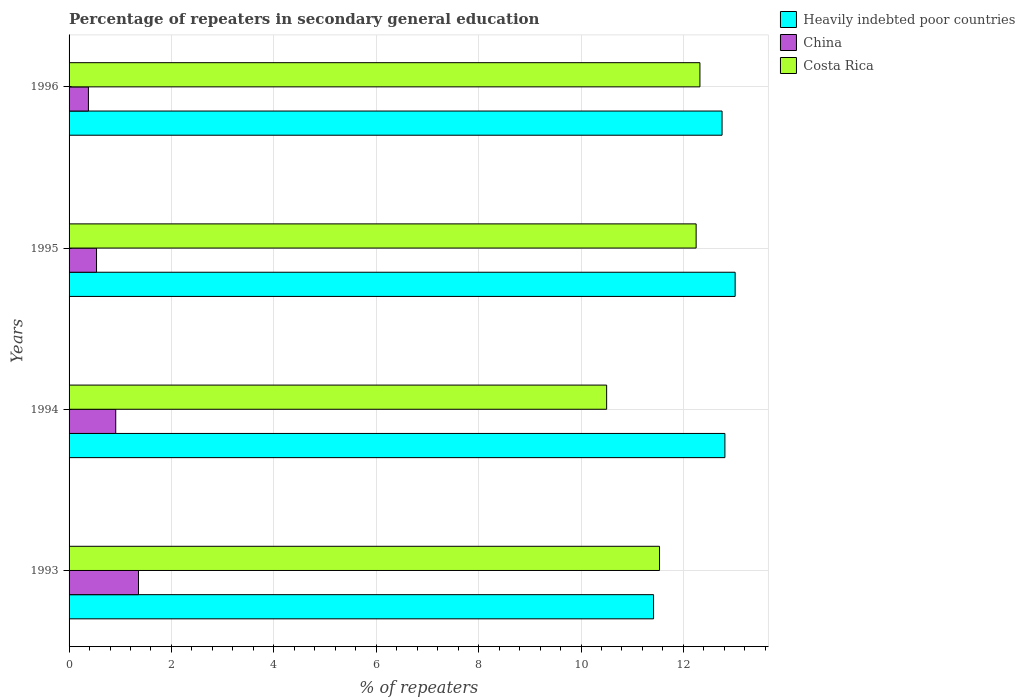How many different coloured bars are there?
Ensure brevity in your answer.  3. How many groups of bars are there?
Your answer should be compact. 4. Are the number of bars per tick equal to the number of legend labels?
Your answer should be compact. Yes. How many bars are there on the 1st tick from the bottom?
Provide a succinct answer. 3. In how many cases, is the number of bars for a given year not equal to the number of legend labels?
Your answer should be compact. 0. What is the percentage of repeaters in secondary general education in Costa Rica in 1996?
Provide a short and direct response. 12.32. Across all years, what is the maximum percentage of repeaters in secondary general education in Heavily indebted poor countries?
Offer a very short reply. 13.01. Across all years, what is the minimum percentage of repeaters in secondary general education in Costa Rica?
Give a very brief answer. 10.5. In which year was the percentage of repeaters in secondary general education in China maximum?
Make the answer very short. 1993. In which year was the percentage of repeaters in secondary general education in Heavily indebted poor countries minimum?
Ensure brevity in your answer.  1993. What is the total percentage of repeaters in secondary general education in Heavily indebted poor countries in the graph?
Give a very brief answer. 50. What is the difference between the percentage of repeaters in secondary general education in China in 1994 and that in 1995?
Your answer should be very brief. 0.38. What is the difference between the percentage of repeaters in secondary general education in Costa Rica in 1994 and the percentage of repeaters in secondary general education in Heavily indebted poor countries in 1993?
Your answer should be very brief. -0.92. What is the average percentage of repeaters in secondary general education in Costa Rica per year?
Your answer should be compact. 11.65. In the year 1995, what is the difference between the percentage of repeaters in secondary general education in China and percentage of repeaters in secondary general education in Heavily indebted poor countries?
Offer a terse response. -12.47. What is the ratio of the percentage of repeaters in secondary general education in China in 1994 to that in 1995?
Ensure brevity in your answer.  1.7. Is the difference between the percentage of repeaters in secondary general education in China in 1994 and 1996 greater than the difference between the percentage of repeaters in secondary general education in Heavily indebted poor countries in 1994 and 1996?
Give a very brief answer. Yes. What is the difference between the highest and the second highest percentage of repeaters in secondary general education in Heavily indebted poor countries?
Your response must be concise. 0.2. What is the difference between the highest and the lowest percentage of repeaters in secondary general education in Costa Rica?
Make the answer very short. 1.82. In how many years, is the percentage of repeaters in secondary general education in China greater than the average percentage of repeaters in secondary general education in China taken over all years?
Offer a very short reply. 2. What does the 3rd bar from the top in 1993 represents?
Give a very brief answer. Heavily indebted poor countries. Does the graph contain any zero values?
Offer a terse response. No. What is the title of the graph?
Ensure brevity in your answer.  Percentage of repeaters in secondary general education. Does "Greenland" appear as one of the legend labels in the graph?
Give a very brief answer. No. What is the label or title of the X-axis?
Make the answer very short. % of repeaters. What is the label or title of the Y-axis?
Provide a succinct answer. Years. What is the % of repeaters of Heavily indebted poor countries in 1993?
Keep it short and to the point. 11.42. What is the % of repeaters of China in 1993?
Your answer should be very brief. 1.36. What is the % of repeaters in Costa Rica in 1993?
Your answer should be very brief. 11.53. What is the % of repeaters in Heavily indebted poor countries in 1994?
Your answer should be compact. 12.81. What is the % of repeaters of China in 1994?
Provide a succinct answer. 0.91. What is the % of repeaters in Costa Rica in 1994?
Your answer should be compact. 10.5. What is the % of repeaters in Heavily indebted poor countries in 1995?
Provide a short and direct response. 13.01. What is the % of repeaters in China in 1995?
Offer a terse response. 0.54. What is the % of repeaters of Costa Rica in 1995?
Ensure brevity in your answer.  12.25. What is the % of repeaters of Heavily indebted poor countries in 1996?
Provide a short and direct response. 12.76. What is the % of repeaters in China in 1996?
Give a very brief answer. 0.38. What is the % of repeaters in Costa Rica in 1996?
Offer a terse response. 12.32. Across all years, what is the maximum % of repeaters in Heavily indebted poor countries?
Offer a terse response. 13.01. Across all years, what is the maximum % of repeaters in China?
Give a very brief answer. 1.36. Across all years, what is the maximum % of repeaters of Costa Rica?
Your answer should be very brief. 12.32. Across all years, what is the minimum % of repeaters in Heavily indebted poor countries?
Provide a short and direct response. 11.42. Across all years, what is the minimum % of repeaters of China?
Ensure brevity in your answer.  0.38. Across all years, what is the minimum % of repeaters of Costa Rica?
Make the answer very short. 10.5. What is the total % of repeaters of Heavily indebted poor countries in the graph?
Make the answer very short. 50. What is the total % of repeaters of China in the graph?
Offer a terse response. 3.18. What is the total % of repeaters in Costa Rica in the graph?
Your answer should be very brief. 46.61. What is the difference between the % of repeaters in Heavily indebted poor countries in 1993 and that in 1994?
Give a very brief answer. -1.39. What is the difference between the % of repeaters in China in 1993 and that in 1994?
Provide a short and direct response. 0.44. What is the difference between the % of repeaters in Costa Rica in 1993 and that in 1994?
Provide a short and direct response. 1.03. What is the difference between the % of repeaters of Heavily indebted poor countries in 1993 and that in 1995?
Offer a terse response. -1.59. What is the difference between the % of repeaters in China in 1993 and that in 1995?
Your answer should be very brief. 0.82. What is the difference between the % of repeaters in Costa Rica in 1993 and that in 1995?
Your answer should be very brief. -0.72. What is the difference between the % of repeaters of Heavily indebted poor countries in 1993 and that in 1996?
Provide a short and direct response. -1.34. What is the difference between the % of repeaters of China in 1993 and that in 1996?
Provide a succinct answer. 0.98. What is the difference between the % of repeaters of Costa Rica in 1993 and that in 1996?
Keep it short and to the point. -0.79. What is the difference between the % of repeaters in Heavily indebted poor countries in 1994 and that in 1995?
Your answer should be compact. -0.2. What is the difference between the % of repeaters in China in 1994 and that in 1995?
Your answer should be compact. 0.38. What is the difference between the % of repeaters in Costa Rica in 1994 and that in 1995?
Keep it short and to the point. -1.75. What is the difference between the % of repeaters of Heavily indebted poor countries in 1994 and that in 1996?
Your answer should be compact. 0.06. What is the difference between the % of repeaters in China in 1994 and that in 1996?
Provide a succinct answer. 0.53. What is the difference between the % of repeaters in Costa Rica in 1994 and that in 1996?
Keep it short and to the point. -1.82. What is the difference between the % of repeaters of Heavily indebted poor countries in 1995 and that in 1996?
Offer a terse response. 0.26. What is the difference between the % of repeaters of China in 1995 and that in 1996?
Give a very brief answer. 0.16. What is the difference between the % of repeaters of Costa Rica in 1995 and that in 1996?
Your answer should be compact. -0.07. What is the difference between the % of repeaters of Heavily indebted poor countries in 1993 and the % of repeaters of China in 1994?
Your answer should be very brief. 10.51. What is the difference between the % of repeaters in Heavily indebted poor countries in 1993 and the % of repeaters in Costa Rica in 1994?
Make the answer very short. 0.92. What is the difference between the % of repeaters in China in 1993 and the % of repeaters in Costa Rica in 1994?
Provide a succinct answer. -9.14. What is the difference between the % of repeaters of Heavily indebted poor countries in 1993 and the % of repeaters of China in 1995?
Ensure brevity in your answer.  10.88. What is the difference between the % of repeaters in Heavily indebted poor countries in 1993 and the % of repeaters in Costa Rica in 1995?
Keep it short and to the point. -0.83. What is the difference between the % of repeaters of China in 1993 and the % of repeaters of Costa Rica in 1995?
Offer a very short reply. -10.89. What is the difference between the % of repeaters in Heavily indebted poor countries in 1993 and the % of repeaters in China in 1996?
Your answer should be very brief. 11.04. What is the difference between the % of repeaters in Heavily indebted poor countries in 1993 and the % of repeaters in Costa Rica in 1996?
Provide a succinct answer. -0.91. What is the difference between the % of repeaters of China in 1993 and the % of repeaters of Costa Rica in 1996?
Make the answer very short. -10.97. What is the difference between the % of repeaters of Heavily indebted poor countries in 1994 and the % of repeaters of China in 1995?
Offer a very short reply. 12.27. What is the difference between the % of repeaters of Heavily indebted poor countries in 1994 and the % of repeaters of Costa Rica in 1995?
Keep it short and to the point. 0.56. What is the difference between the % of repeaters in China in 1994 and the % of repeaters in Costa Rica in 1995?
Your answer should be very brief. -11.34. What is the difference between the % of repeaters of Heavily indebted poor countries in 1994 and the % of repeaters of China in 1996?
Your answer should be very brief. 12.43. What is the difference between the % of repeaters in Heavily indebted poor countries in 1994 and the % of repeaters in Costa Rica in 1996?
Your response must be concise. 0.49. What is the difference between the % of repeaters in China in 1994 and the % of repeaters in Costa Rica in 1996?
Your answer should be very brief. -11.41. What is the difference between the % of repeaters in Heavily indebted poor countries in 1995 and the % of repeaters in China in 1996?
Provide a short and direct response. 12.63. What is the difference between the % of repeaters in Heavily indebted poor countries in 1995 and the % of repeaters in Costa Rica in 1996?
Offer a very short reply. 0.69. What is the difference between the % of repeaters in China in 1995 and the % of repeaters in Costa Rica in 1996?
Your response must be concise. -11.79. What is the average % of repeaters in Heavily indebted poor countries per year?
Your response must be concise. 12.5. What is the average % of repeaters in China per year?
Give a very brief answer. 0.8. What is the average % of repeaters of Costa Rica per year?
Offer a terse response. 11.65. In the year 1993, what is the difference between the % of repeaters of Heavily indebted poor countries and % of repeaters of China?
Your answer should be compact. 10.06. In the year 1993, what is the difference between the % of repeaters of Heavily indebted poor countries and % of repeaters of Costa Rica?
Offer a terse response. -0.12. In the year 1993, what is the difference between the % of repeaters in China and % of repeaters in Costa Rica?
Make the answer very short. -10.18. In the year 1994, what is the difference between the % of repeaters in Heavily indebted poor countries and % of repeaters in China?
Provide a short and direct response. 11.9. In the year 1994, what is the difference between the % of repeaters in Heavily indebted poor countries and % of repeaters in Costa Rica?
Give a very brief answer. 2.31. In the year 1994, what is the difference between the % of repeaters of China and % of repeaters of Costa Rica?
Make the answer very short. -9.59. In the year 1995, what is the difference between the % of repeaters of Heavily indebted poor countries and % of repeaters of China?
Ensure brevity in your answer.  12.47. In the year 1995, what is the difference between the % of repeaters in Heavily indebted poor countries and % of repeaters in Costa Rica?
Your answer should be very brief. 0.76. In the year 1995, what is the difference between the % of repeaters in China and % of repeaters in Costa Rica?
Give a very brief answer. -11.71. In the year 1996, what is the difference between the % of repeaters in Heavily indebted poor countries and % of repeaters in China?
Your answer should be very brief. 12.38. In the year 1996, what is the difference between the % of repeaters of Heavily indebted poor countries and % of repeaters of Costa Rica?
Offer a very short reply. 0.43. In the year 1996, what is the difference between the % of repeaters in China and % of repeaters in Costa Rica?
Offer a terse response. -11.95. What is the ratio of the % of repeaters of Heavily indebted poor countries in 1993 to that in 1994?
Ensure brevity in your answer.  0.89. What is the ratio of the % of repeaters of China in 1993 to that in 1994?
Offer a terse response. 1.49. What is the ratio of the % of repeaters in Costa Rica in 1993 to that in 1994?
Provide a short and direct response. 1.1. What is the ratio of the % of repeaters of Heavily indebted poor countries in 1993 to that in 1995?
Your answer should be very brief. 0.88. What is the ratio of the % of repeaters of China in 1993 to that in 1995?
Provide a short and direct response. 2.53. What is the ratio of the % of repeaters of Costa Rica in 1993 to that in 1995?
Your answer should be very brief. 0.94. What is the ratio of the % of repeaters of Heavily indebted poor countries in 1993 to that in 1996?
Ensure brevity in your answer.  0.9. What is the ratio of the % of repeaters in China in 1993 to that in 1996?
Your answer should be compact. 3.59. What is the ratio of the % of repeaters in Costa Rica in 1993 to that in 1996?
Offer a very short reply. 0.94. What is the ratio of the % of repeaters of Heavily indebted poor countries in 1994 to that in 1995?
Give a very brief answer. 0.98. What is the ratio of the % of repeaters of China in 1994 to that in 1995?
Offer a terse response. 1.7. What is the ratio of the % of repeaters of Costa Rica in 1994 to that in 1995?
Your answer should be compact. 0.86. What is the ratio of the % of repeaters of Heavily indebted poor countries in 1994 to that in 1996?
Offer a very short reply. 1. What is the ratio of the % of repeaters in China in 1994 to that in 1996?
Make the answer very short. 2.41. What is the ratio of the % of repeaters in Costa Rica in 1994 to that in 1996?
Offer a terse response. 0.85. What is the ratio of the % of repeaters of Heavily indebted poor countries in 1995 to that in 1996?
Your response must be concise. 1.02. What is the ratio of the % of repeaters in China in 1995 to that in 1996?
Provide a succinct answer. 1.42. What is the difference between the highest and the second highest % of repeaters in Heavily indebted poor countries?
Your answer should be compact. 0.2. What is the difference between the highest and the second highest % of repeaters in China?
Ensure brevity in your answer.  0.44. What is the difference between the highest and the second highest % of repeaters in Costa Rica?
Provide a short and direct response. 0.07. What is the difference between the highest and the lowest % of repeaters of Heavily indebted poor countries?
Your answer should be compact. 1.59. What is the difference between the highest and the lowest % of repeaters in China?
Keep it short and to the point. 0.98. What is the difference between the highest and the lowest % of repeaters in Costa Rica?
Your answer should be compact. 1.82. 